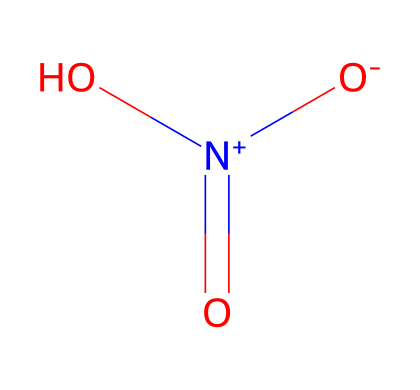What is the molecular formula of this chemical? By analyzing the SMILES representation O=[N+]([O-])O, we can identify the atoms present. The elements are nitrogen (N), oxygen (O), and hydrogen (H). Counting them, we find one nitrogen atom, three oxygen atoms, and one hydrogen atom, leading to the formula HNO3.
Answer: HNO3 How many total atoms are present in this chemical? In the molecular formula HNO3, we see there is 1 hydrogen, 1 nitrogen, and 3 oxygen atoms. Adding these together gives a total of 1 + 1 + 3 = 5 atoms.
Answer: 5 What charge does the nitrogen have in this chemical? The SMILES representation shows the nitrogen atom connected to an oxygen atom with a positive charge ([N+]). This indicates that the nitrogen has a positive formal charge.
Answer: positive Is this chemical a strong or weak oxidizer? Nitric acid is known for being a strong oxidizing agent due to its ability to donate oxygen. Its structure, featuring nitrogen in a high oxidation state, supports this behavior.
Answer: strong What other functional group is present in nitric acid based on its structure? The presence of the -OH (hydroxyl) group in the structure O=[N+]([O-])O indicates that nitric acid contains an alcohol functional group which characterizes it as an acid.
Answer: hydroxyl How many double bonds are present in this chemical's structure? In the structural interpretation of the SMILES notation, there is one double bond between nitrogen and the oxygen atom (O=[N+]). Thus, there is a single double bond in the molecule.
Answer: 1 What type of reaction does nitric acid commonly undergo as an oxidizer? Due to its characteristics, nitric acid typically participates in oxidation reactions, facilitating the transfer of electrons. This is evident from its strong oxidizing properties observed in many chemical processes.
Answer: oxidation 